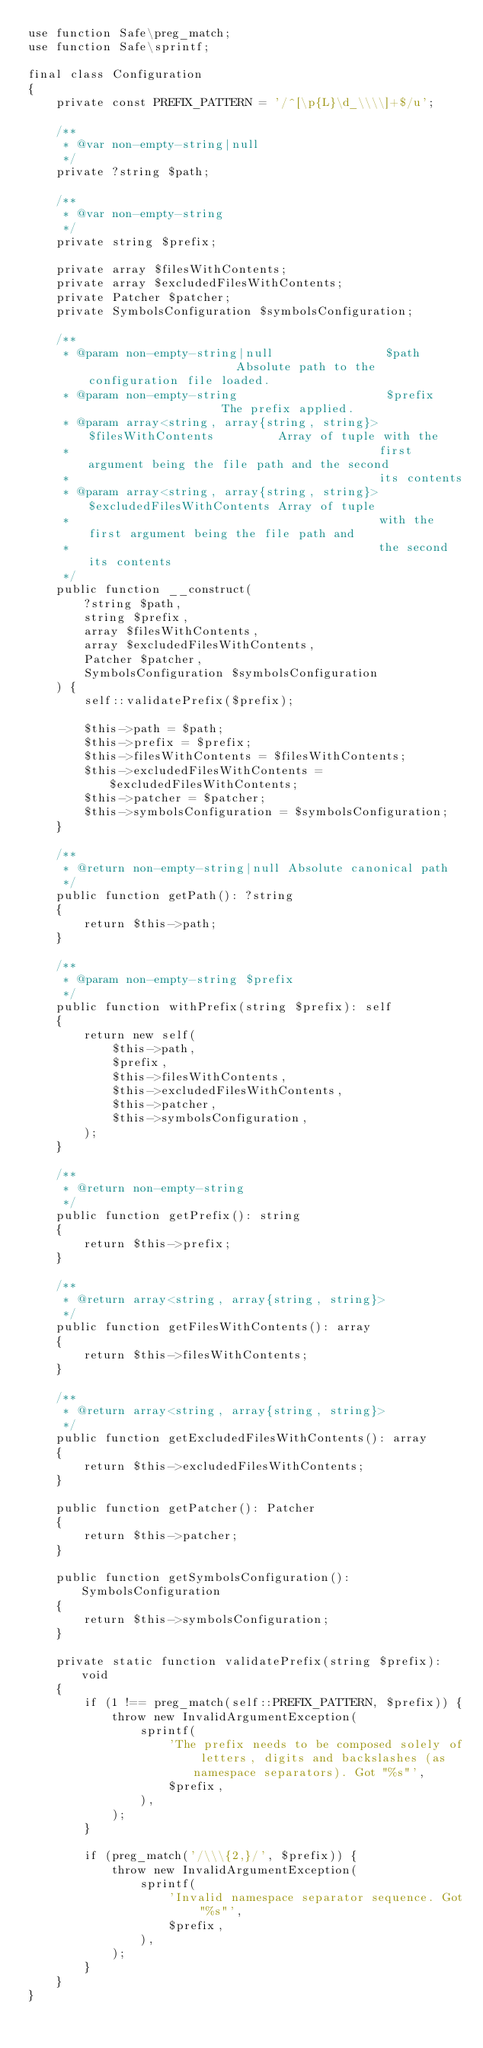Convert code to text. <code><loc_0><loc_0><loc_500><loc_500><_PHP_>use function Safe\preg_match;
use function Safe\sprintf;

final class Configuration
{
    private const PREFIX_PATTERN = '/^[\p{L}\d_\\\\]+$/u';

    /**
     * @var non-empty-string|null
     */
    private ?string $path;

    /**
     * @var non-empty-string
     */
    private string $prefix;

    private array $filesWithContents;
    private array $excludedFilesWithContents;
    private Patcher $patcher;
    private SymbolsConfiguration $symbolsConfiguration;

    /**
     * @param non-empty-string|null                $path                      Absolute path to the configuration file loaded.
     * @param non-empty-string                     $prefix                    The prefix applied.
     * @param array<string, array{string, string}> $filesWithContents         Array of tuple with the
     *                                            first argument being the file path and the second
     *                                            its contents
     * @param array<string, array{string, string}> $excludedFilesWithContents Array of tuple
     *                                            with the first argument being the file path and
     *                                            the second its contents
     */
    public function __construct(
        ?string $path,
        string $prefix,
        array $filesWithContents,
        array $excludedFilesWithContents,
        Patcher $patcher,
        SymbolsConfiguration $symbolsConfiguration
    ) {
        self::validatePrefix($prefix);

        $this->path = $path;
        $this->prefix = $prefix;
        $this->filesWithContents = $filesWithContents;
        $this->excludedFilesWithContents = $excludedFilesWithContents;
        $this->patcher = $patcher;
        $this->symbolsConfiguration = $symbolsConfiguration;
    }

    /**
     * @return non-empty-string|null Absolute canonical path
     */
    public function getPath(): ?string
    {
        return $this->path;
    }

    /**
     * @param non-empty-string $prefix
     */
    public function withPrefix(string $prefix): self
    {
        return new self(
            $this->path,
            $prefix,
            $this->filesWithContents,
            $this->excludedFilesWithContents,
            $this->patcher,
            $this->symbolsConfiguration,
        );
    }

    /**
     * @return non-empty-string
     */
    public function getPrefix(): string
    {
        return $this->prefix;
    }

    /**
     * @return array<string, array{string, string}>
     */
    public function getFilesWithContents(): array
    {
        return $this->filesWithContents;
    }

    /**
     * @return array<string, array{string, string}>
     */
    public function getExcludedFilesWithContents(): array
    {
        return $this->excludedFilesWithContents;
    }

    public function getPatcher(): Patcher
    {
        return $this->patcher;
    }

    public function getSymbolsConfiguration(): SymbolsConfiguration
    {
        return $this->symbolsConfiguration;
    }

    private static function validatePrefix(string $prefix): void
    {
        if (1 !== preg_match(self::PREFIX_PATTERN, $prefix)) {
            throw new InvalidArgumentException(
                sprintf(
                    'The prefix needs to be composed solely of letters, digits and backslashes (as namespace separators). Got "%s"',
                    $prefix,
                ),
            );
        }

        if (preg_match('/\\\{2,}/', $prefix)) {
            throw new InvalidArgumentException(
                sprintf(
                    'Invalid namespace separator sequence. Got "%s"',
                    $prefix,
                ),
            );
        }
    }
}
</code> 